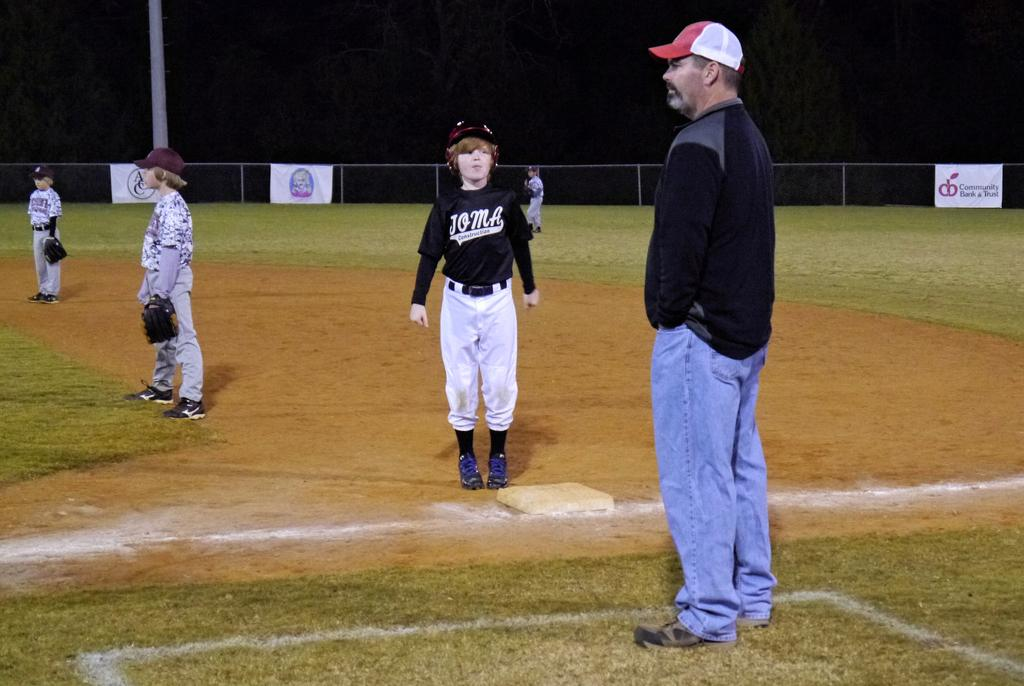Provide a one-sentence caption for the provided image. children playing baseball and sign on fence for community bank & trust. 